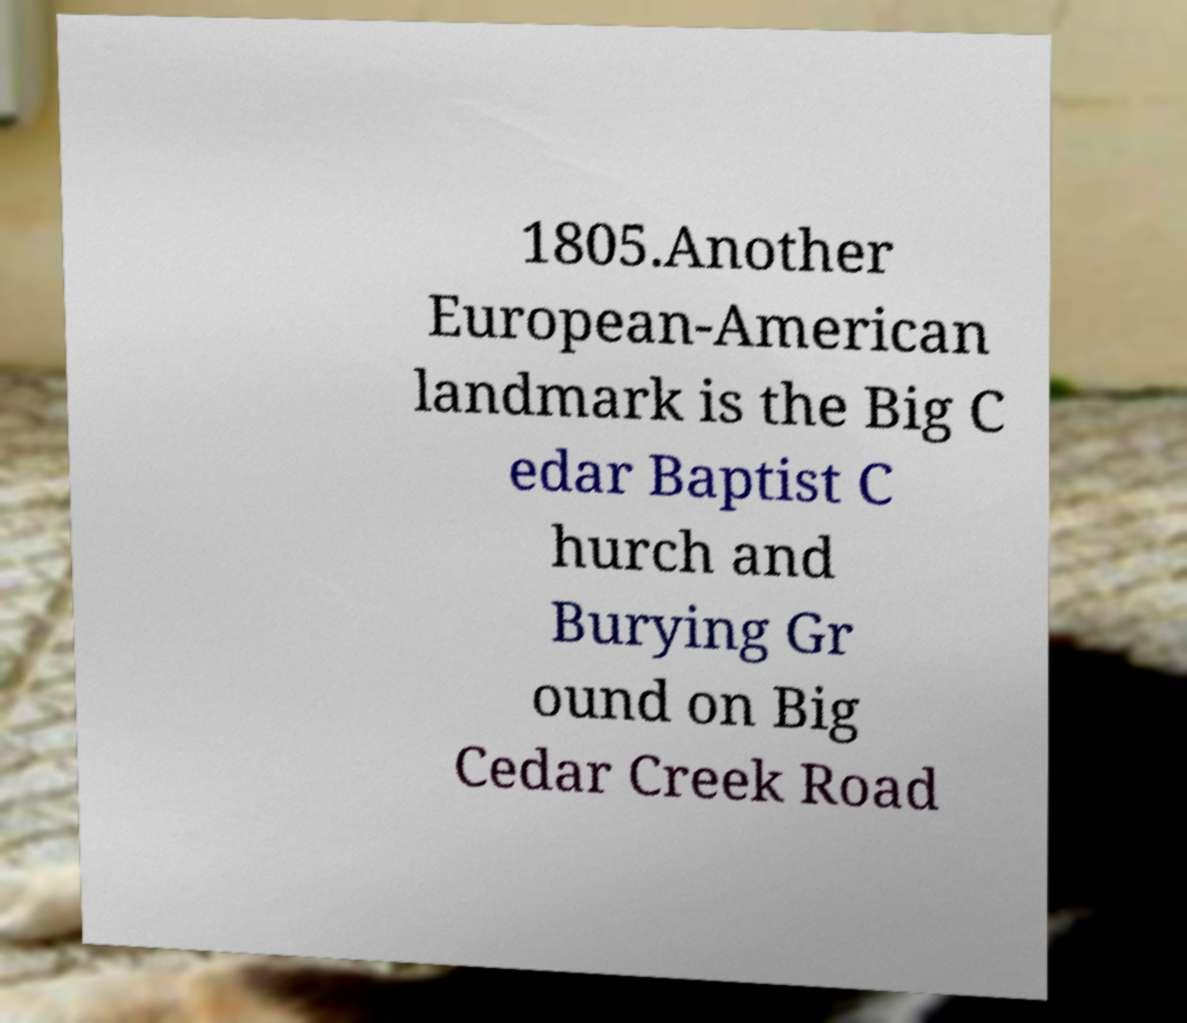For documentation purposes, I need the text within this image transcribed. Could you provide that? 1805.Another European-American landmark is the Big C edar Baptist C hurch and Burying Gr ound on Big Cedar Creek Road 